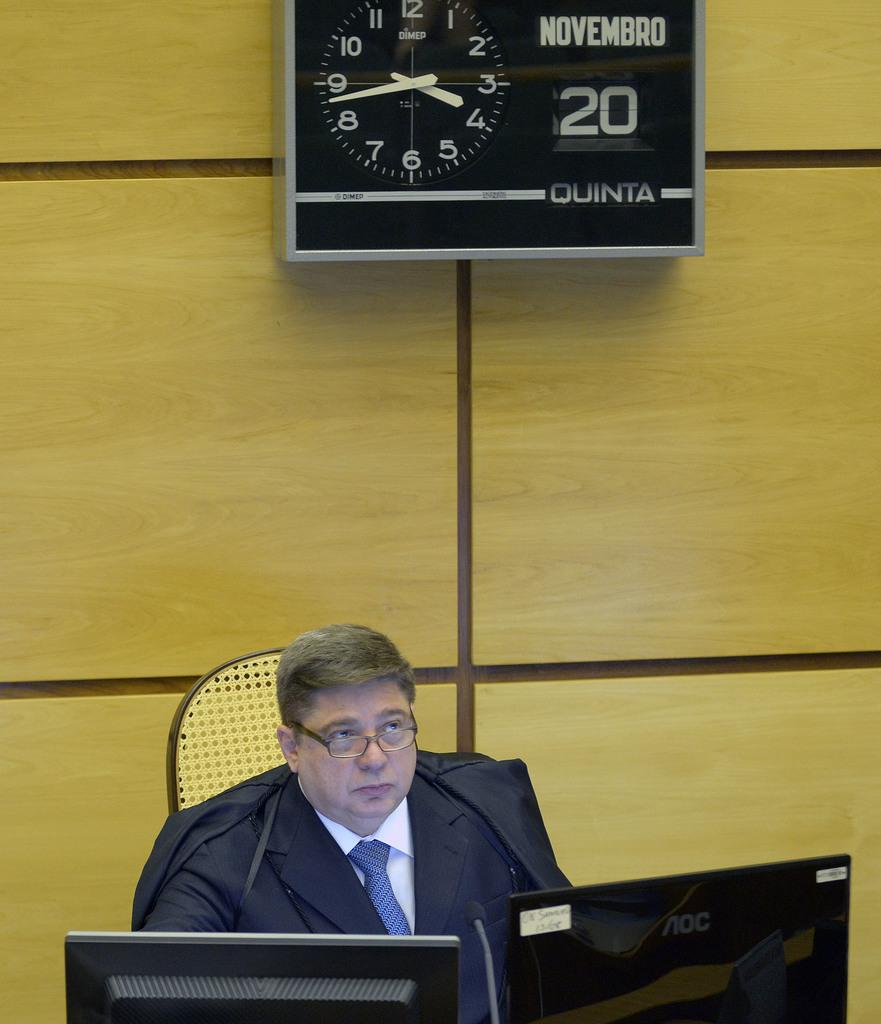<image>
Relay a brief, clear account of the picture shown. A displeased-looking man sits under a clock that says it's the 20th of November. 